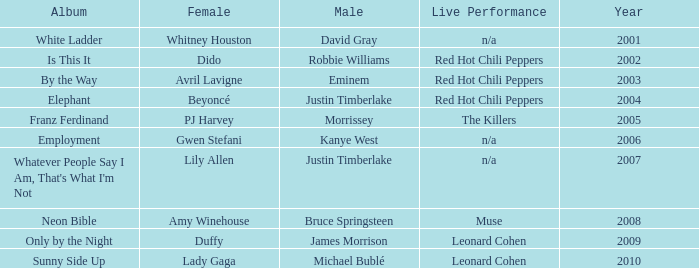Which male is paired with dido in 2004? Robbie Williams. 